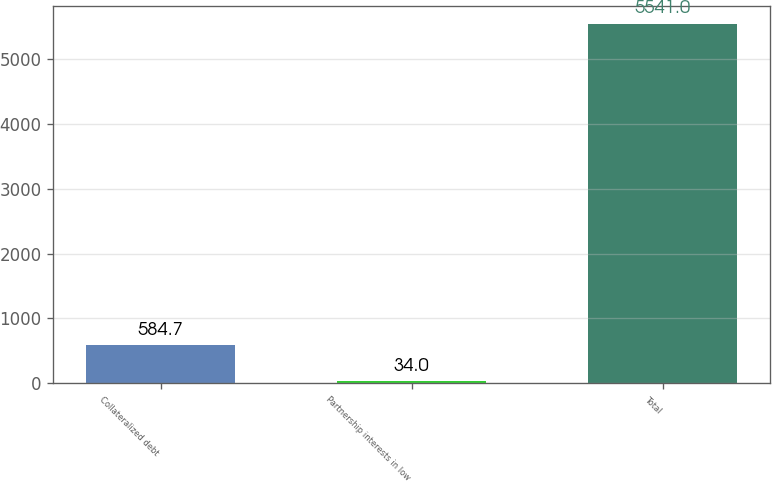Convert chart. <chart><loc_0><loc_0><loc_500><loc_500><bar_chart><fcel>Collateralized debt<fcel>Partnership interests in low<fcel>Total<nl><fcel>584.7<fcel>34<fcel>5541<nl></chart> 